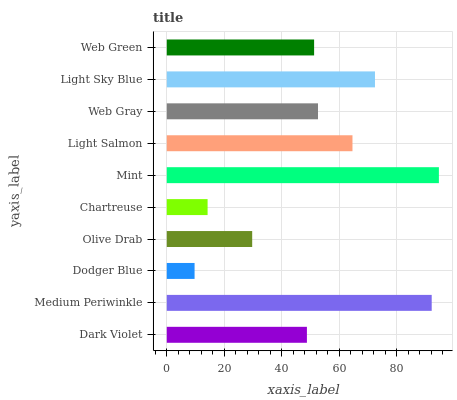Is Dodger Blue the minimum?
Answer yes or no. Yes. Is Mint the maximum?
Answer yes or no. Yes. Is Medium Periwinkle the minimum?
Answer yes or no. No. Is Medium Periwinkle the maximum?
Answer yes or no. No. Is Medium Periwinkle greater than Dark Violet?
Answer yes or no. Yes. Is Dark Violet less than Medium Periwinkle?
Answer yes or no. Yes. Is Dark Violet greater than Medium Periwinkle?
Answer yes or no. No. Is Medium Periwinkle less than Dark Violet?
Answer yes or no. No. Is Web Gray the high median?
Answer yes or no. Yes. Is Web Green the low median?
Answer yes or no. Yes. Is Chartreuse the high median?
Answer yes or no. No. Is Light Sky Blue the low median?
Answer yes or no. No. 